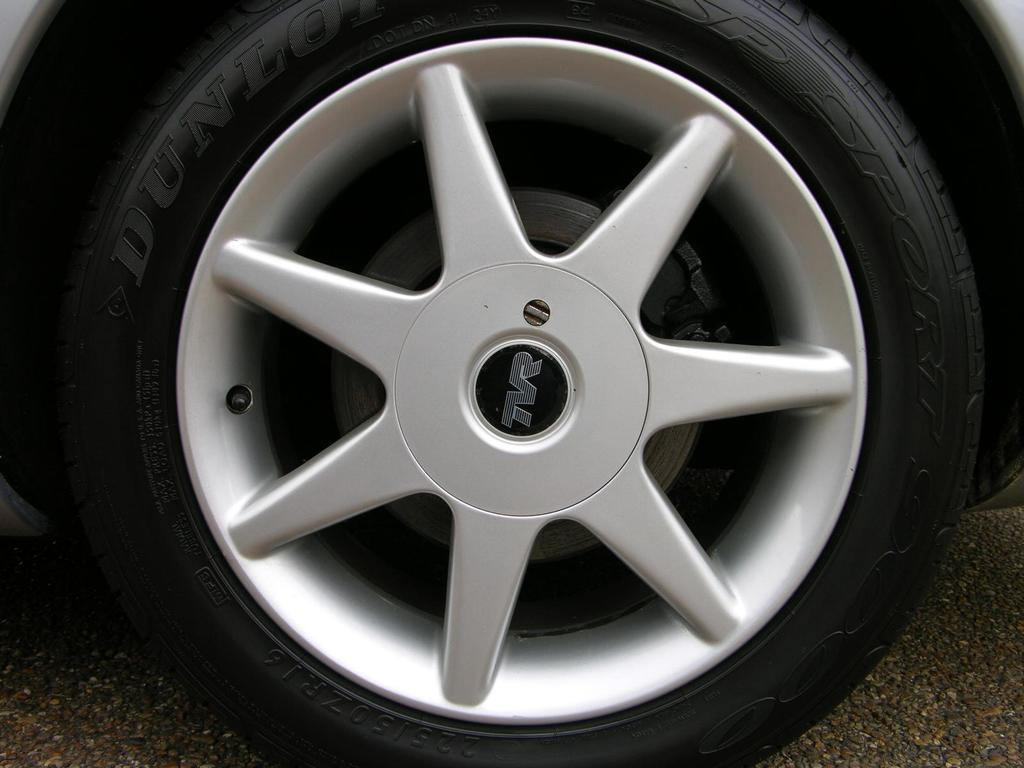What object is the main focus of the image? The main focus of the image is a car tire. What is the color of the rim of the tire? The rim of the tire is gray in color. What is the color of the tire itself? The tire itself is black in color. Where is the tire and rim located in the image? The tire and rim are on a path. What type of spark can be seen coming from the office in the image? There is no office or spark present in the image; it features a car tire and rim on a path. 